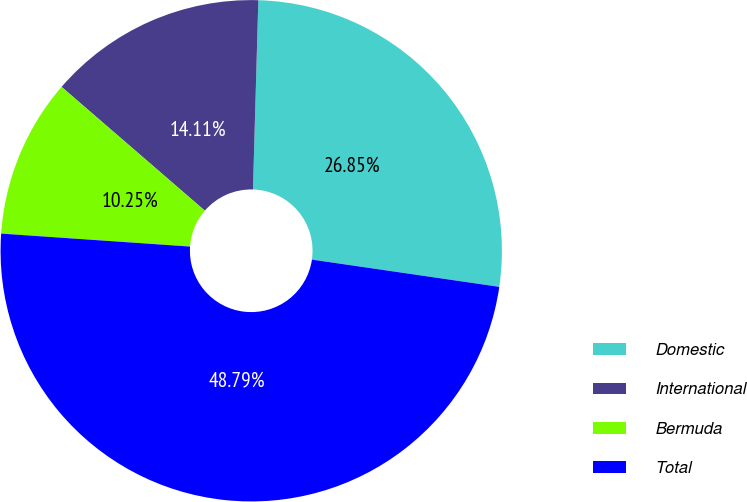Convert chart to OTSL. <chart><loc_0><loc_0><loc_500><loc_500><pie_chart><fcel>Domestic<fcel>International<fcel>Bermuda<fcel>Total<nl><fcel>26.85%<fcel>14.11%<fcel>10.25%<fcel>48.79%<nl></chart> 